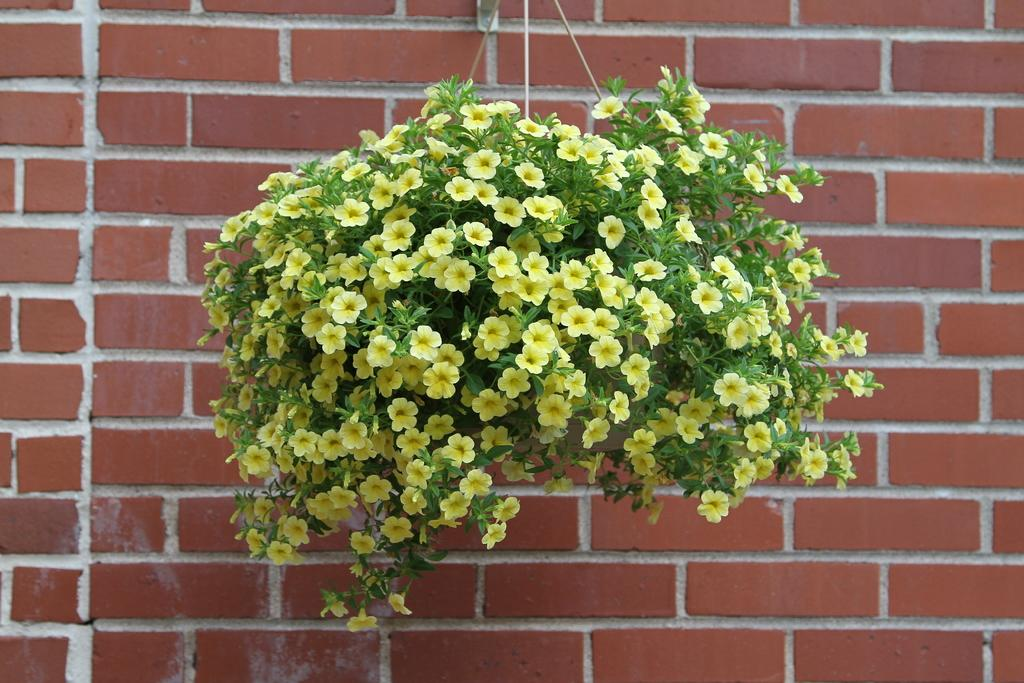What is the main subject of the image? There is a plant in the middle of the image. What color are the flowers on the plant? The plant has yellow flowers. What can be seen in the background of the image? There is a wall in the background of the image. How is the plant being watered in the image? There is no indication in the image that the plant is being watered. What type of precipitation can be seen falling from the sky in the image? There is no precipitation, such as sleet, visible in the image. 